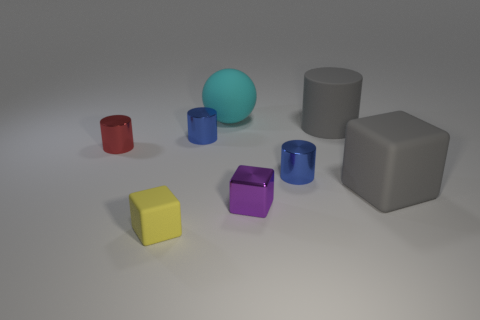Subtract 1 cylinders. How many cylinders are left? 3 Subtract all tiny red metallic cylinders. How many cylinders are left? 3 Subtract all brown cylinders. Subtract all purple spheres. How many cylinders are left? 4 Add 2 large cylinders. How many objects exist? 10 Subtract all spheres. How many objects are left? 7 Subtract 0 brown balls. How many objects are left? 8 Subtract all tiny red shiny cylinders. Subtract all balls. How many objects are left? 6 Add 6 red things. How many red things are left? 7 Add 7 cyan things. How many cyan things exist? 8 